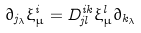Convert formula to latex. <formula><loc_0><loc_0><loc_500><loc_500>\partial _ { j _ { \lambda } } \xi ^ { i } _ { \mu } = D ^ { i k } _ { j l } \xi ^ { l } _ { \mu } \partial _ { k _ { \lambda } }</formula> 